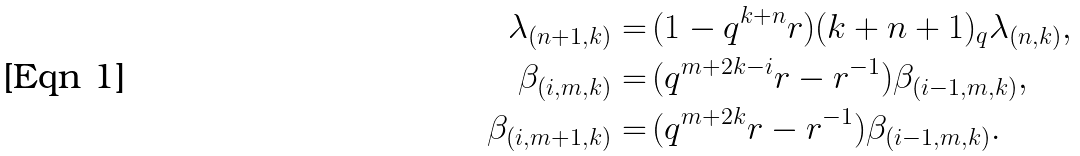<formula> <loc_0><loc_0><loc_500><loc_500>\lambda _ { ( n + 1 , k ) } = & \, ( 1 - q ^ { k + n } r ) ( k + n + 1 ) _ { q } \lambda _ { ( n , k ) } , \\ \beta _ { ( i , m , k ) } = & \, ( q ^ { m + 2 k - i } r - r ^ { - 1 } ) \beta _ { ( i - 1 , m , k ) } , \\ \beta _ { ( i , m + 1 , k ) } = & \, ( q ^ { m + 2 k } r - r ^ { - 1 } ) \beta _ { ( i - 1 , m , k ) } .</formula> 